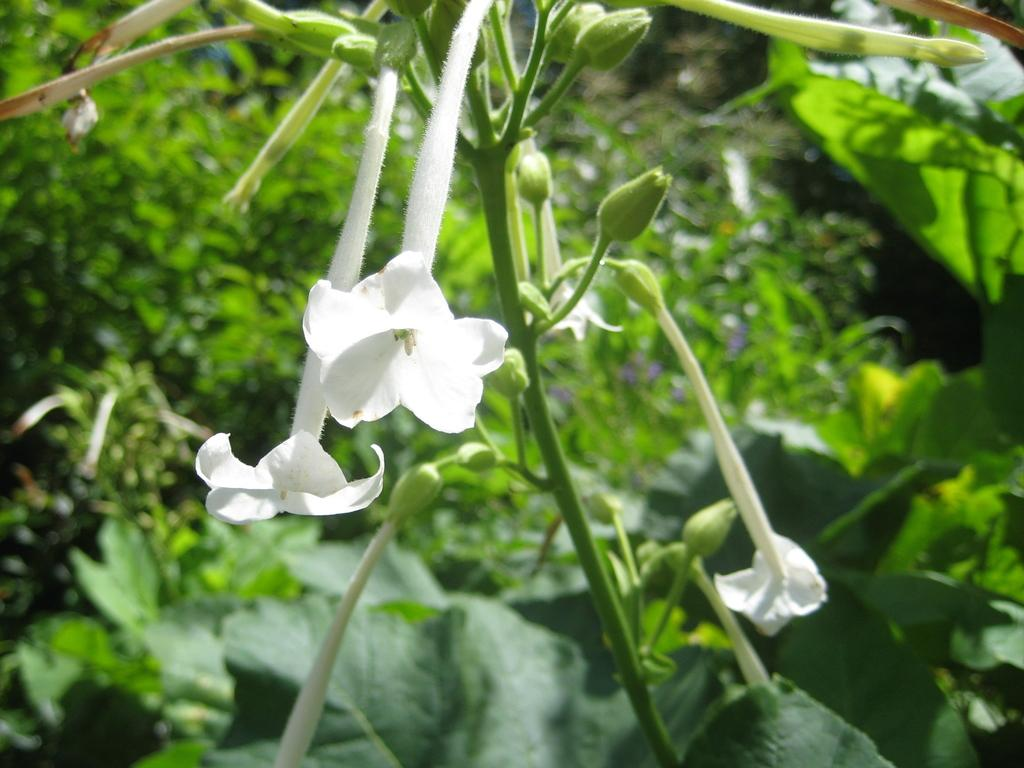What type of plant is in the image? There is a flower plant in the image. What part of the plant is visible in the image? Leaves are visible in the image. What can be seen in the background of the image? There are plants in the background of the image. How many spiders are crawling on the flower in the image? There are no spiders visible in the image; it only features a flower plant and leaves. What type of trail can be seen in the image? There is no trail present in the image; it only contains a flower plant, leaves, and background plants. 